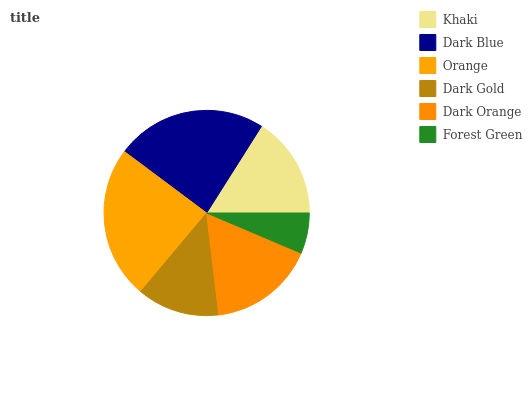Is Forest Green the minimum?
Answer yes or no. Yes. Is Orange the maximum?
Answer yes or no. Yes. Is Dark Blue the minimum?
Answer yes or no. No. Is Dark Blue the maximum?
Answer yes or no. No. Is Dark Blue greater than Khaki?
Answer yes or no. Yes. Is Khaki less than Dark Blue?
Answer yes or no. Yes. Is Khaki greater than Dark Blue?
Answer yes or no. No. Is Dark Blue less than Khaki?
Answer yes or no. No. Is Dark Orange the high median?
Answer yes or no. Yes. Is Khaki the low median?
Answer yes or no. Yes. Is Dark Gold the high median?
Answer yes or no. No. Is Dark Blue the low median?
Answer yes or no. No. 